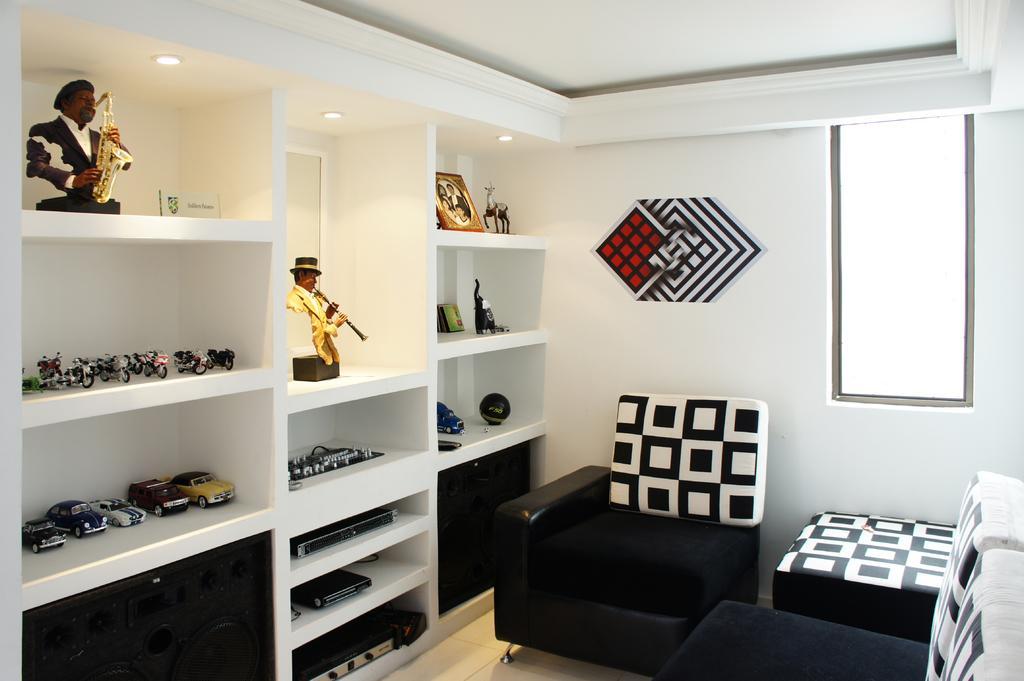Describe this image in one or two sentences. This picture describes about interior of the room, in this we can find sofas, and also we can see few toys and a frame in the racks. 